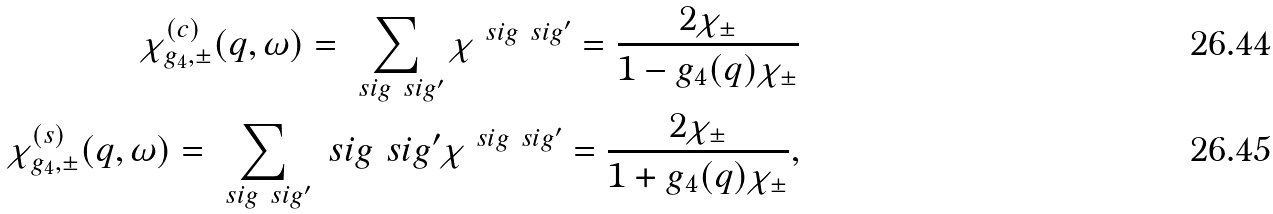Convert formula to latex. <formula><loc_0><loc_0><loc_500><loc_500>\chi ^ { ( c ) } _ { g _ { 4 } , \pm } ( q , \omega ) = \sum _ { \ s i g \ s i g ^ { \prime } } \chi ^ { \ s i g \ s i g ^ { \prime } } = \frac { 2 \chi _ { \pm } } { 1 - g _ { 4 } ( q ) \chi _ { \pm } } \\ \chi ^ { ( s ) } _ { g _ { 4 } , \pm } ( q , \omega ) = \sum _ { \ s i g \ s i g ^ { \prime } } \ s i g \ s i g ^ { \prime } \chi ^ { \ s i g \ s i g ^ { \prime } } = \frac { 2 \chi _ { \pm } } { 1 + g _ { 4 } ( q ) \chi _ { \pm } } ,</formula> 